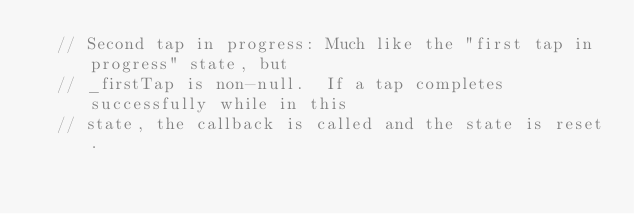<code> <loc_0><loc_0><loc_500><loc_500><_Dart_>  // Second tap in progress: Much like the "first tap in progress" state, but
  // _firstTap is non-null.  If a tap completes successfully while in this
  // state, the callback is called and the state is reset.</code> 